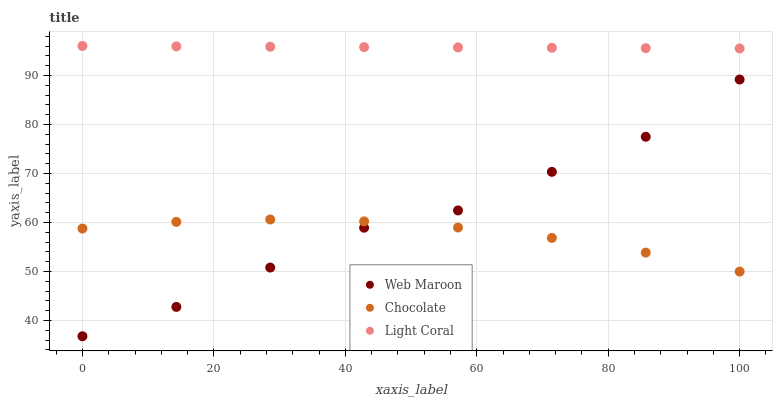Does Chocolate have the minimum area under the curve?
Answer yes or no. Yes. Does Light Coral have the maximum area under the curve?
Answer yes or no. Yes. Does Web Maroon have the minimum area under the curve?
Answer yes or no. No. Does Web Maroon have the maximum area under the curve?
Answer yes or no. No. Is Light Coral the smoothest?
Answer yes or no. Yes. Is Web Maroon the roughest?
Answer yes or no. Yes. Is Chocolate the smoothest?
Answer yes or no. No. Is Chocolate the roughest?
Answer yes or no. No. Does Web Maroon have the lowest value?
Answer yes or no. Yes. Does Chocolate have the lowest value?
Answer yes or no. No. Does Light Coral have the highest value?
Answer yes or no. Yes. Does Web Maroon have the highest value?
Answer yes or no. No. Is Web Maroon less than Light Coral?
Answer yes or no. Yes. Is Light Coral greater than Chocolate?
Answer yes or no. Yes. Does Chocolate intersect Web Maroon?
Answer yes or no. Yes. Is Chocolate less than Web Maroon?
Answer yes or no. No. Is Chocolate greater than Web Maroon?
Answer yes or no. No. Does Web Maroon intersect Light Coral?
Answer yes or no. No. 